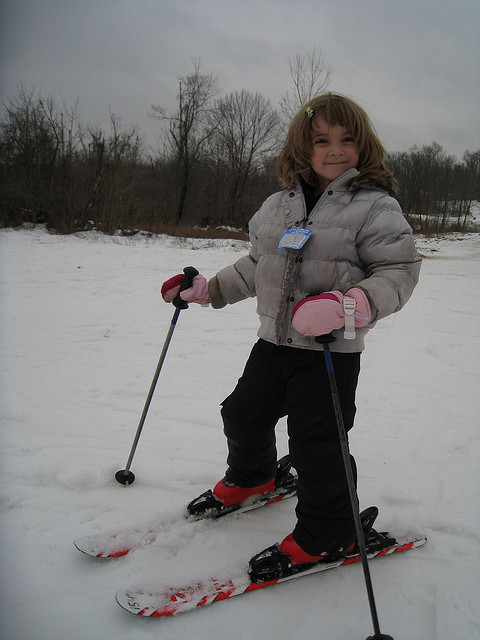What equipment is the girl using to ski? The girl is equipped with a pair of skis that feature a floral pattern and poles with red handles, suited for her size and perfect for a beginner. Do you think the size of her equipment is appropriate for her age? Yes, the skis and poles appear to be the right size for a child her age, ensuring her safety and enjoyment while skiing. 